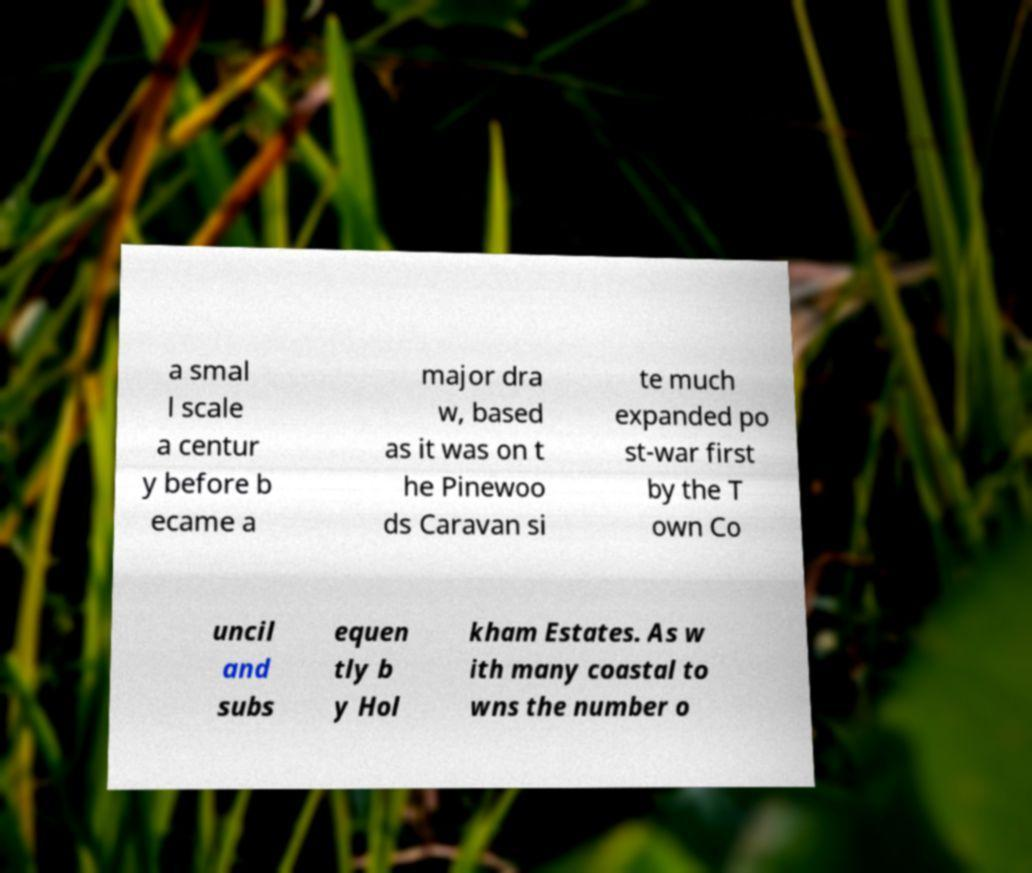I need the written content from this picture converted into text. Can you do that? a smal l scale a centur y before b ecame a major dra w, based as it was on t he Pinewoo ds Caravan si te much expanded po st-war first by the T own Co uncil and subs equen tly b y Hol kham Estates. As w ith many coastal to wns the number o 